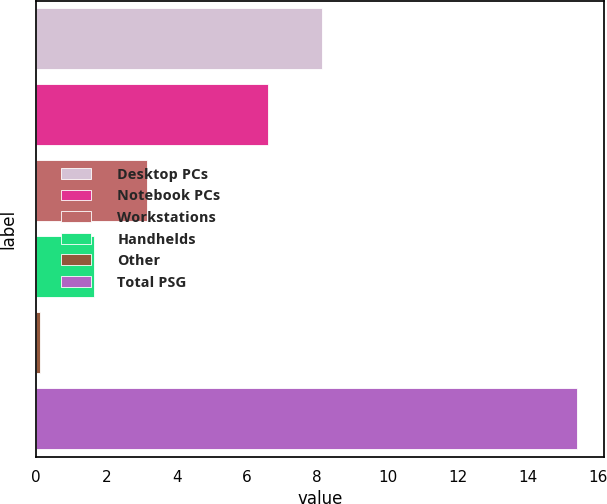<chart> <loc_0><loc_0><loc_500><loc_500><bar_chart><fcel>Desktop PCs<fcel>Notebook PCs<fcel>Workstations<fcel>Handhelds<fcel>Other<fcel>Total PSG<nl><fcel>8.13<fcel>6.6<fcel>3.16<fcel>1.63<fcel>0.1<fcel>15.4<nl></chart> 